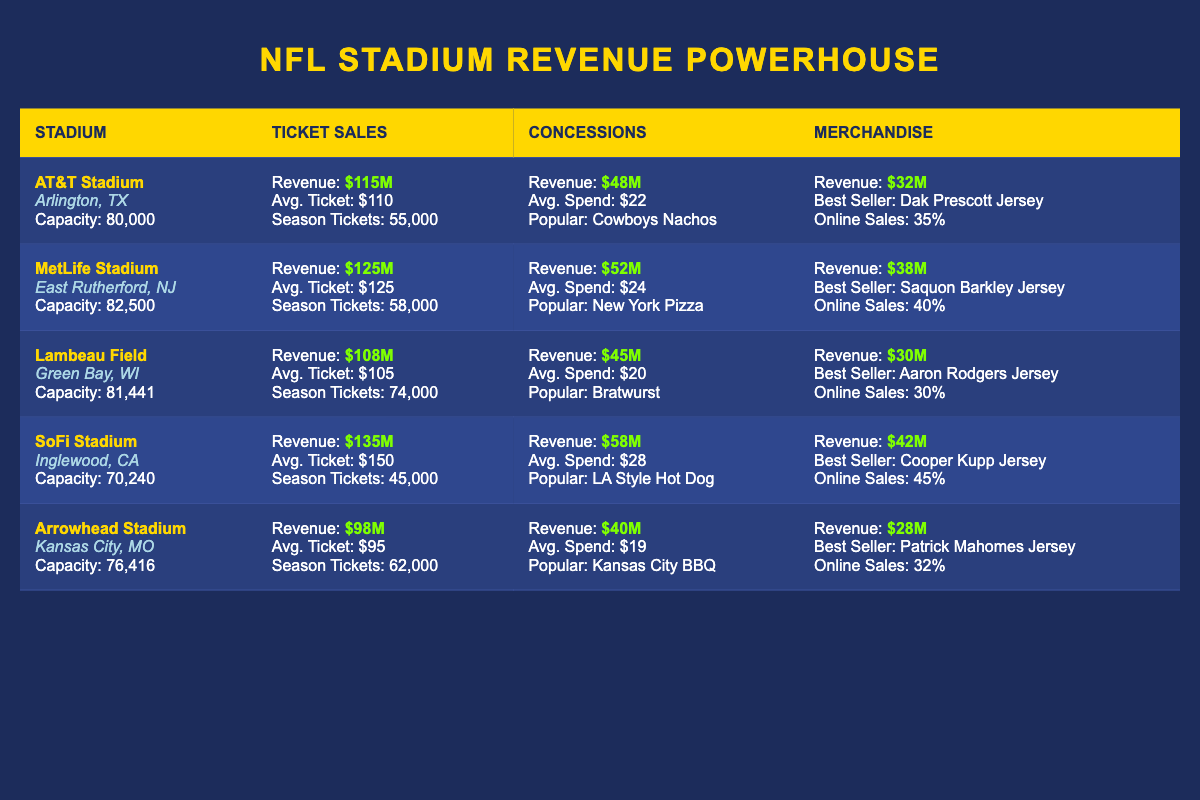What is the total annual revenue from ticket sales for all stadiums combined? To find the total annual revenue from ticket sales, we need to add the individual ticket sale revenues from each stadium: $115M + $125M + $108M + $135M + $98M = $681M.
Answer: $681M Which stadium has the highest average ticket price? Looking at the average ticket prices listed, SoFi Stadium has the highest average ticket price at $150.
Answer: SoFi Stadium Is the most popular item in concessions at Arrowhead Stadium a type of BBQ? According to the data, the most popular item at Arrowhead Stadium is Kansas City BBQ, which confirms the statement.
Answer: Yes What is the total merchandise revenue for Lambeau Field and Arrowhead Stadium combined? The total merchandise revenue is calculated by adding Lambeau Field's revenue of $30M and Arrowhead Stadium's revenue of $28M: $30M + $28M = $58M.
Answer: $58M Does MetLife Stadium have more season ticket holders than AT&T Stadium? MetLife Stadium has 58,000 season ticket holders while AT&T Stadium has 55,000, which means MetLife Stadium has more.
Answer: Yes What is the average spend per fan for concessions across all stadiums? To calculate the average spend, we take the sum of average spend per fan from each stadium ($22 + $24 + $20 + $28 + $19) and divide by the number of stadiums which is 5: (22 + 24 + 20 + 28 + 19) / 5 = 22.6.
Answer: $22.6 Which stadium located in Texas has the lowest ticket sales revenue? The Texas stadium referred to is AT&T Stadium with a ticket sales revenue of $115M, and by comparing that with revenues from other stadiums, it is indeed lower than at SoFi Stadium, so it is also the lowest in Texas.
Answer: AT&T Stadium How many season ticket holders does SoFi Stadium have? Looking directly at the stadium entry for SoFi Stadium, it states there are 45,000 season ticket holders.
Answer: 45,000 What is the difference in annual revenue from concessions between SoFi Stadium and Lambeau Field? To find this difference, we subtract Lambeau Field’s concessions revenue ($45M) from SoFi Stadium’s revenue ($58M): $58M - $45M = $13M.
Answer: $13M What is the average online sales percentage for merchandise across all stadiums? We need to find the average of the online sales percentages: (35% + 40% + 30% + 45% + 32%) / 5 = 36.4%.
Answer: 36.4% 